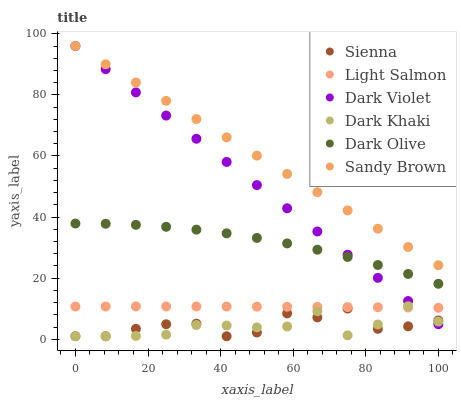Does Dark Khaki have the minimum area under the curve?
Answer yes or no. Yes. Does Sandy Brown have the maximum area under the curve?
Answer yes or no. Yes. Does Light Salmon have the minimum area under the curve?
Answer yes or no. No. Does Light Salmon have the maximum area under the curve?
Answer yes or no. No. Is Dark Violet the smoothest?
Answer yes or no. Yes. Is Dark Khaki the roughest?
Answer yes or no. Yes. Is Light Salmon the smoothest?
Answer yes or no. No. Is Light Salmon the roughest?
Answer yes or no. No. Does Dark Khaki have the lowest value?
Answer yes or no. Yes. Does Light Salmon have the lowest value?
Answer yes or no. No. Does Sandy Brown have the highest value?
Answer yes or no. Yes. Does Light Salmon have the highest value?
Answer yes or no. No. Is Sienna less than Dark Olive?
Answer yes or no. Yes. Is Light Salmon greater than Sienna?
Answer yes or no. Yes. Does Dark Olive intersect Dark Violet?
Answer yes or no. Yes. Is Dark Olive less than Dark Violet?
Answer yes or no. No. Is Dark Olive greater than Dark Violet?
Answer yes or no. No. Does Sienna intersect Dark Olive?
Answer yes or no. No. 